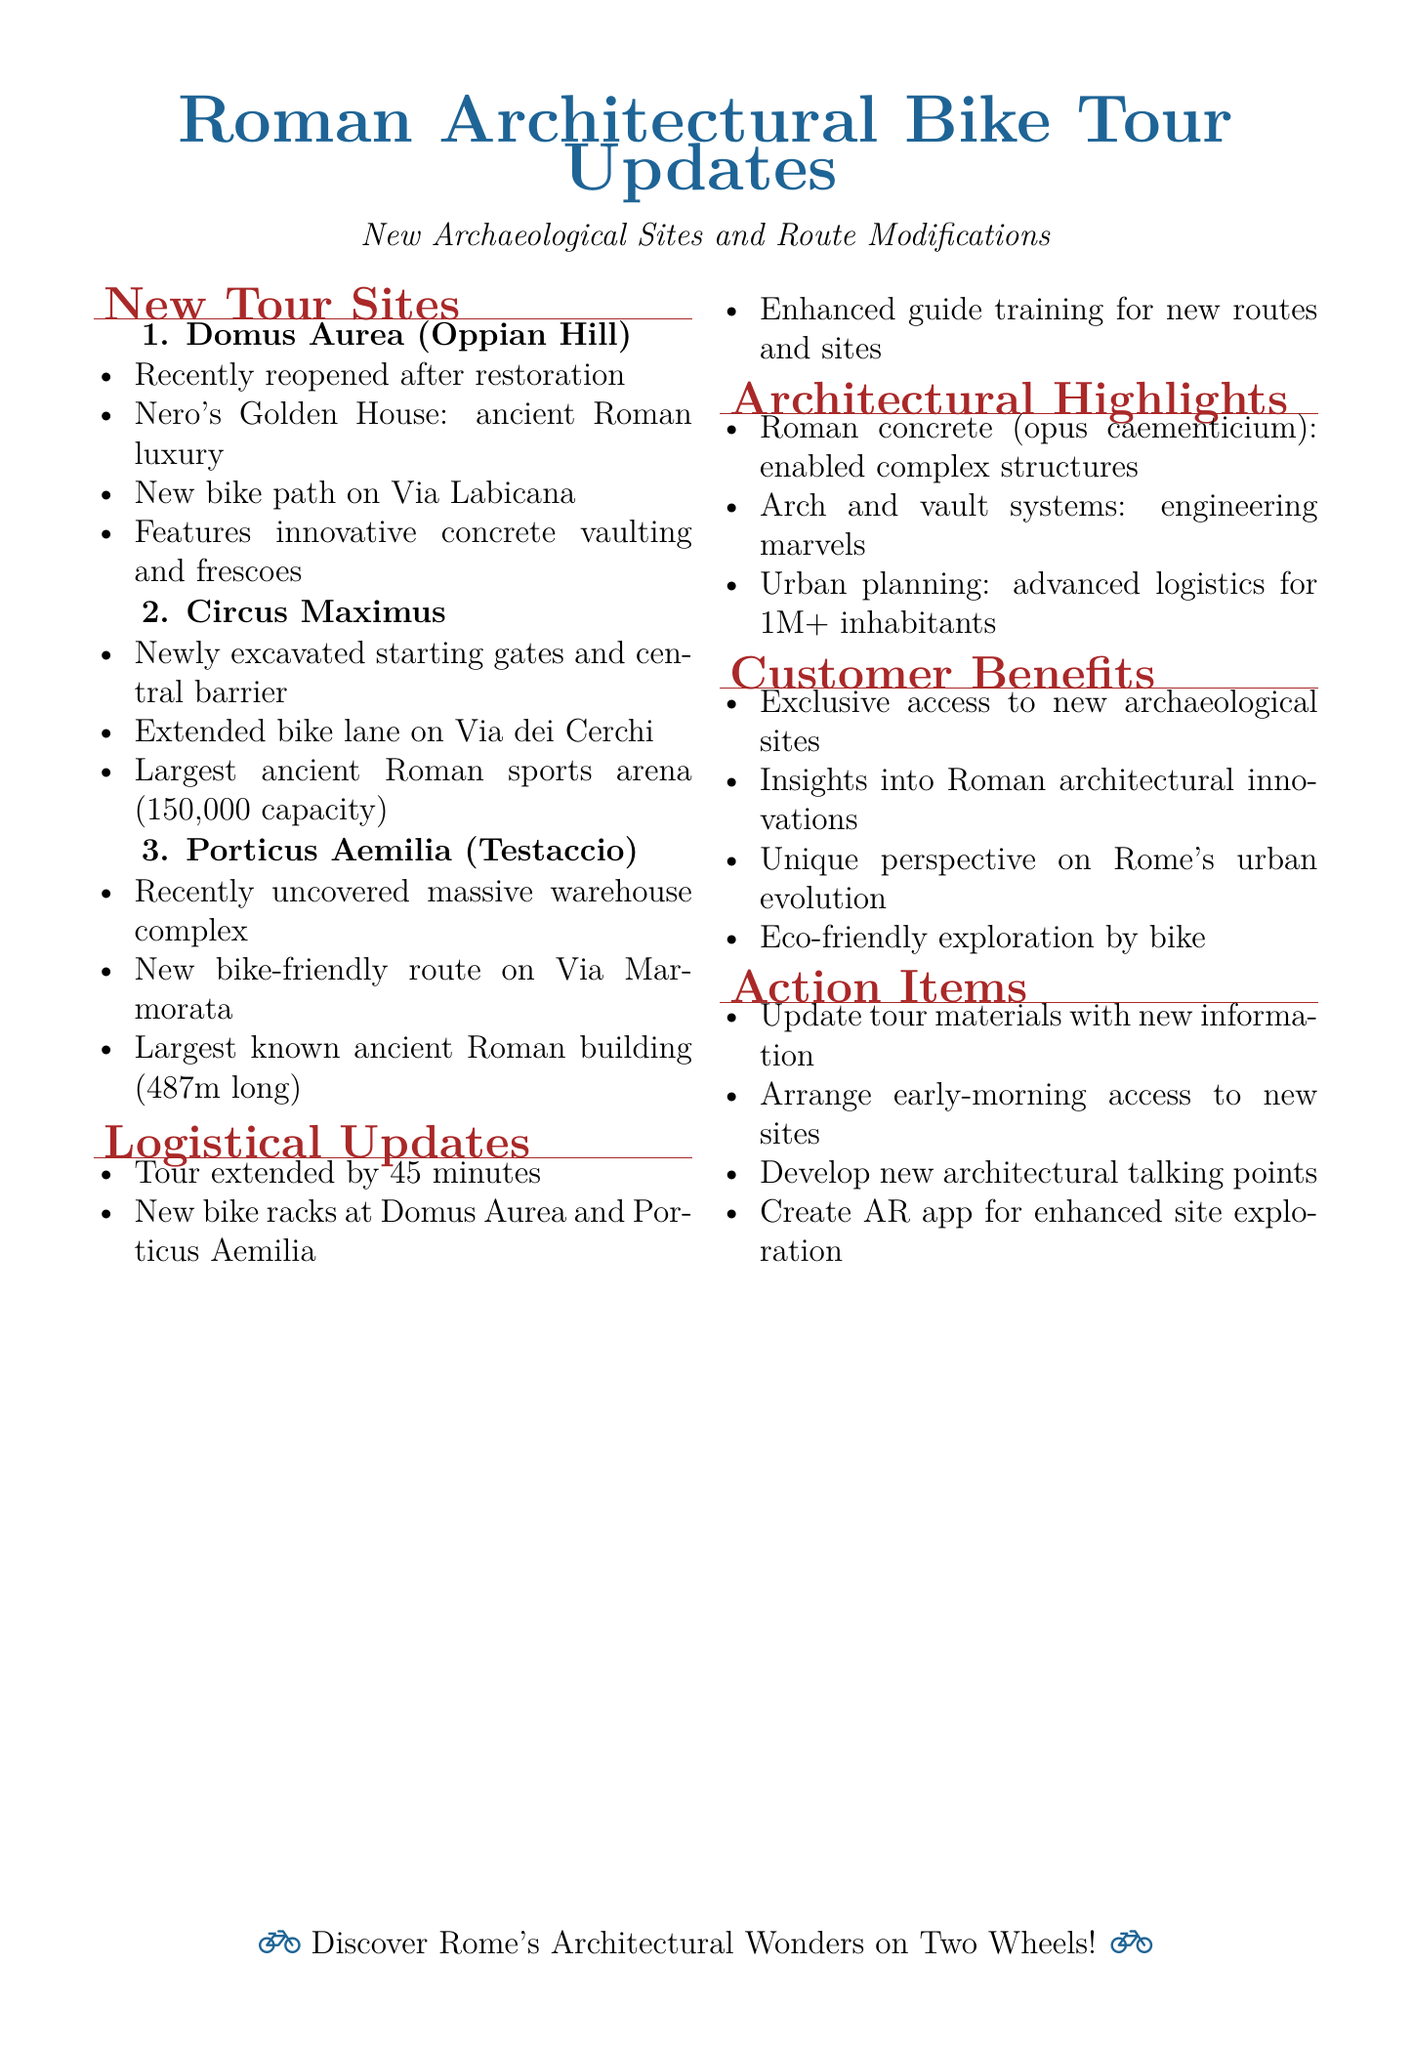What is the name of the recently reopened site? The document states that the Domus Aurea has been reopened after restoration.
Answer: Domus Aurea Where is the Circus Maximus located? The document specifies that the Circus Maximus is situated in the valley between the Aventine and Palatine Hills.
Answer: Valley between Aventine and Palatine Hills What is the length of the Porticus Aemilia? The document mentions that the Porticus Aemilia spans 487 meters, making it the largest known building in ancient Rome.
Answer: 487 meters How long is the standard tour extended to accommodate new sites? According to the logistical updates in the document, the standard tour duration is extended by 45 minutes.
Answer: 45 minutes What innovative material is highlighted in the architectural features? The document identifies Roman concrete (opus caementicium) as a revolutionary building material.
Answer: Roman concrete What solution is proposed for bike parking? The document states that new bike racks should be installed near the entrances of Domus Aurea and Porticus Aemilia.
Answer: New bike racks Which feature exemplifies Roman engineering at the Circus Maximus? The document refers to the specific arch and vault systems demonstrated in the site as an example of Roman engineering prowess.
Answer: Arch and vault systems What is one customer benefit mentioned in the document? The document lists several benefits, one of which is exclusive access to newly opened archaeological sites.
Answer: Exclusive access to new archaeological sites 